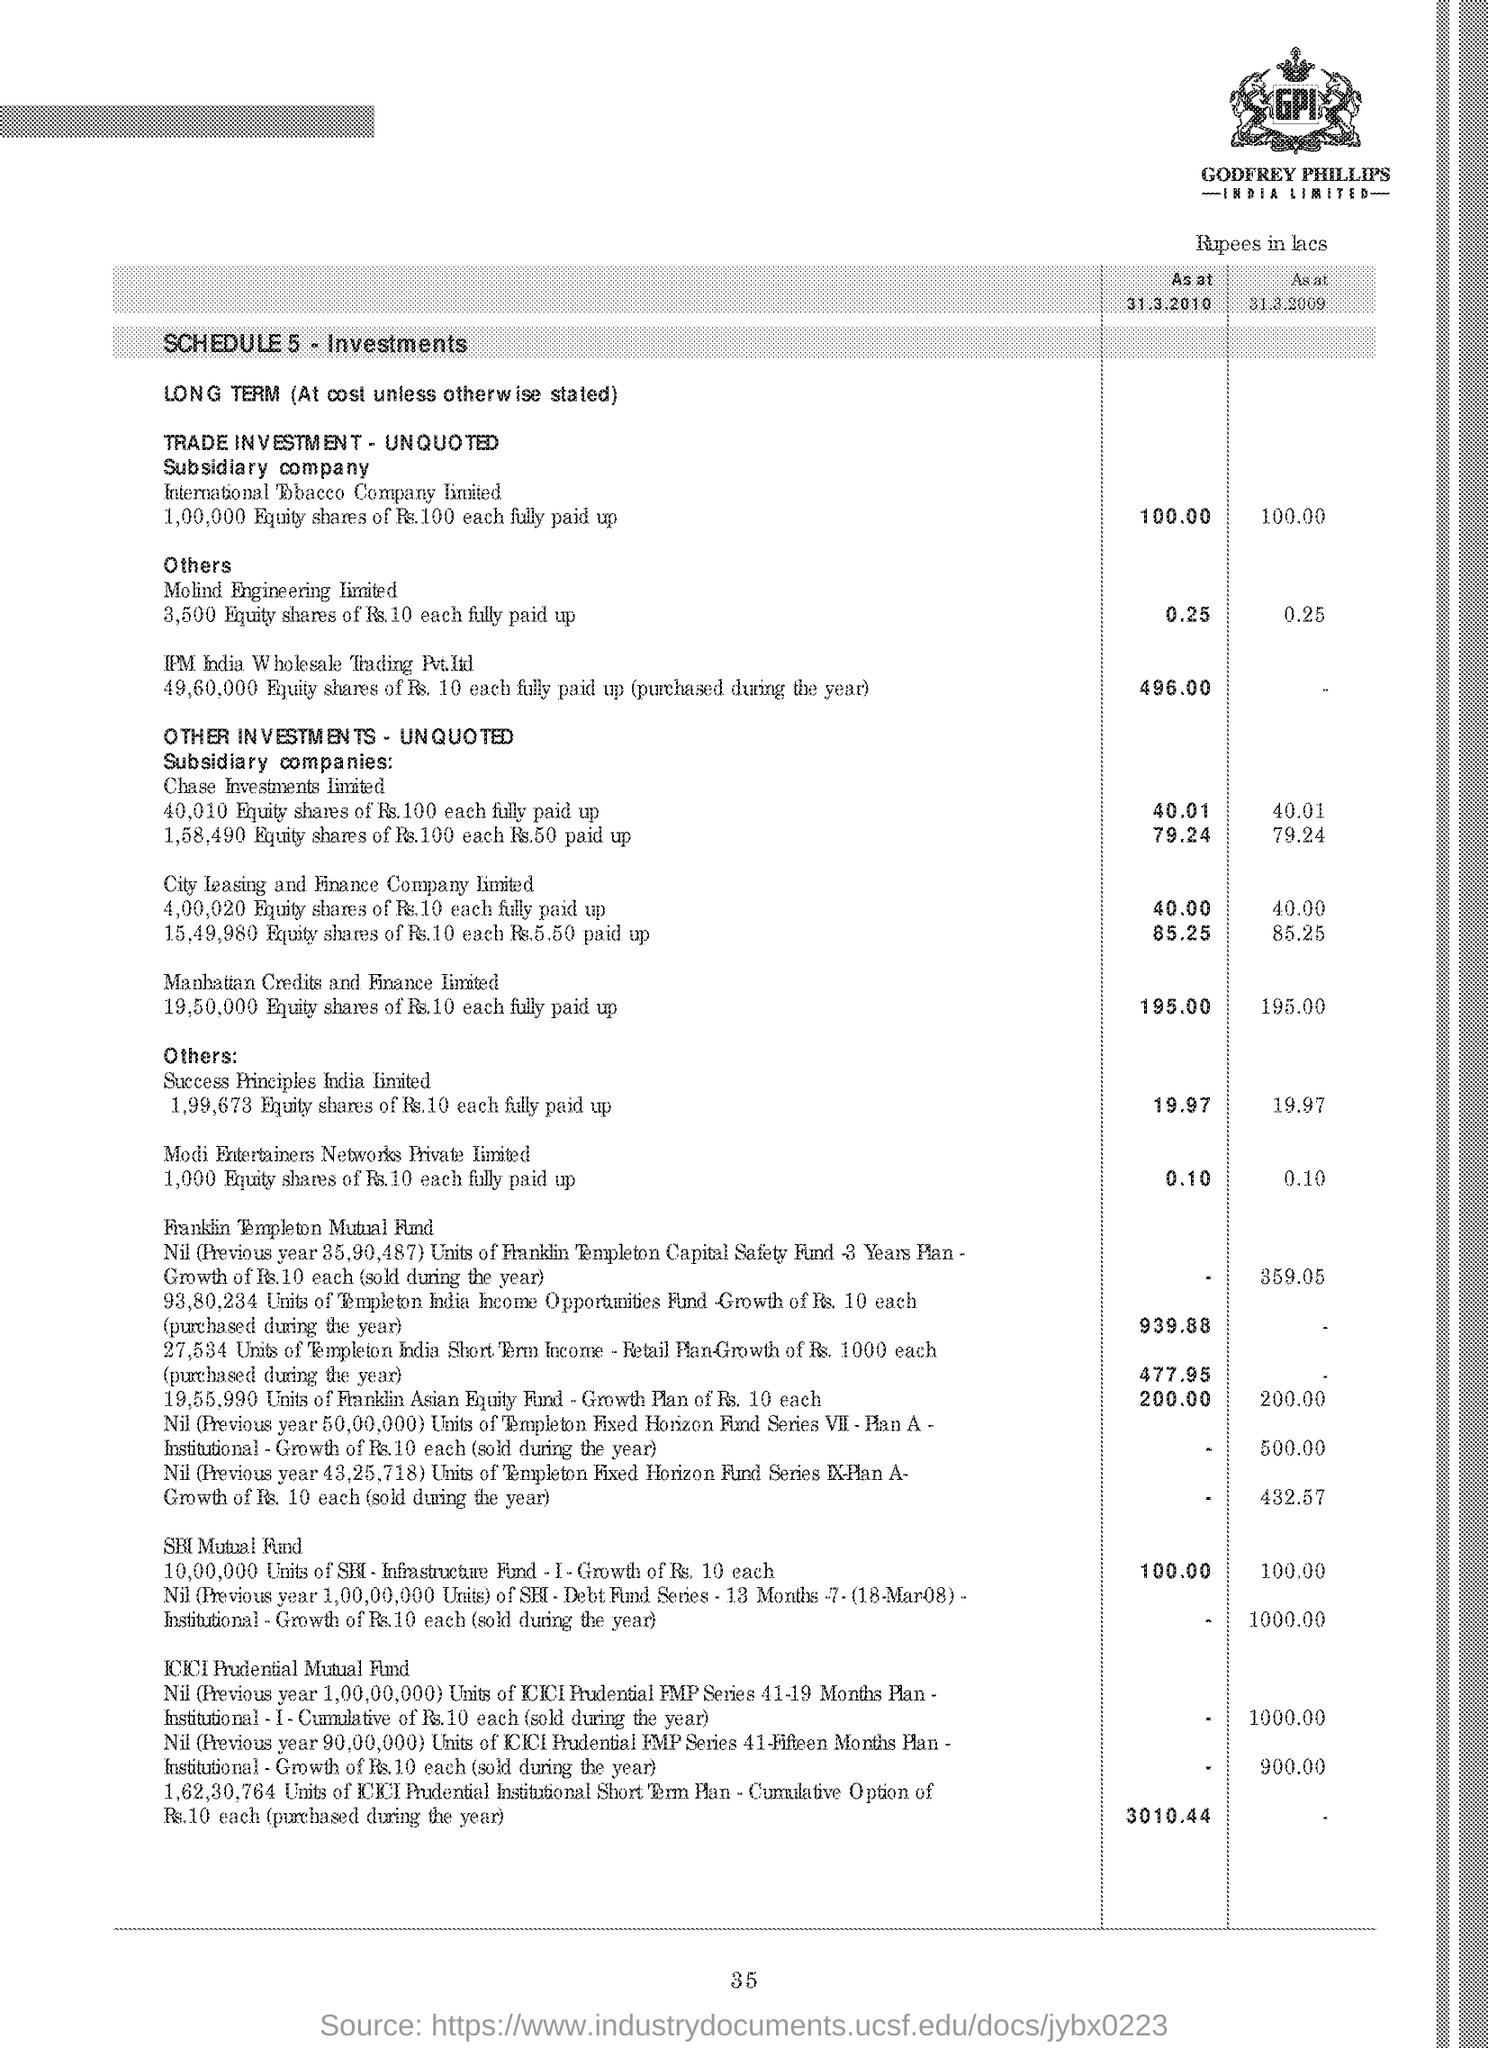Identify some key points in this picture. There is no information in the table for IPM India Wholesale Trading Pvt. Ltd. for the period from 31.3.2009. The schedule number, as per the document, is 5. The amount shown for SBI Mutual Fund as of March 31, 2010, was 100.00. 